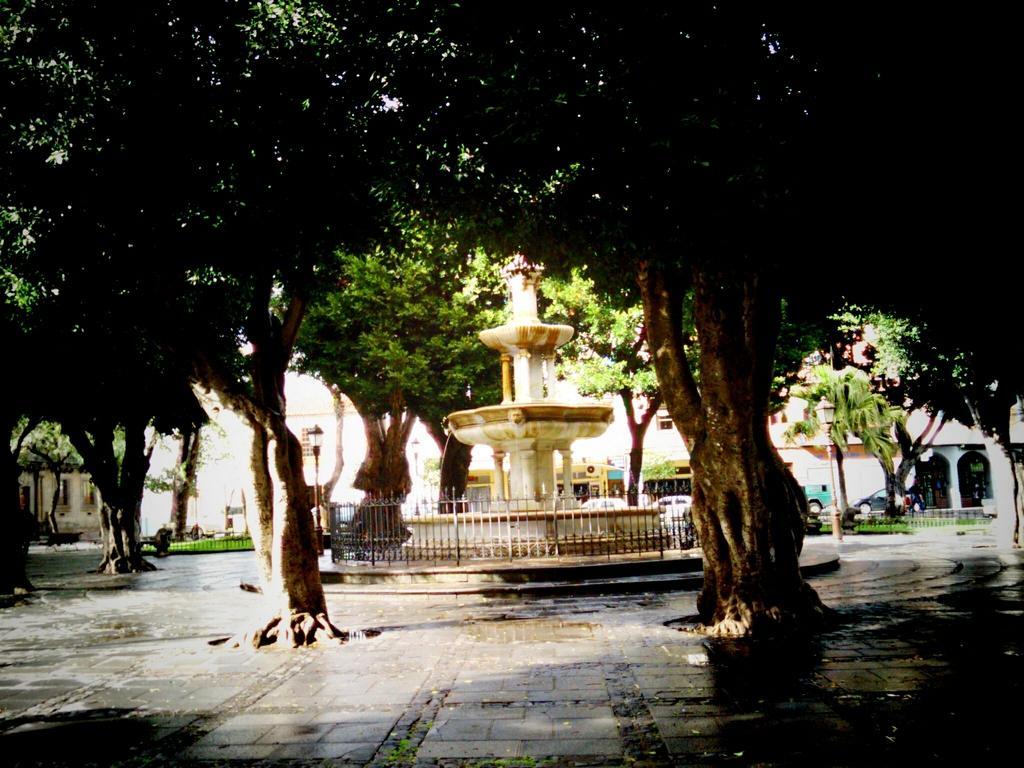What is the main feature in the center of the image? There is a fountain in the middle of the image. What surrounds the fountain? There are many trees around the fountain. What can be seen in the distance behind the fountain? There is a building in the background of the image. What else is visible in the background? There are vehicles visible in the background of the image. What type of coat is draped over the fountain in the image? There is no coat present in the image; it features a fountain surrounded by trees and a building in the background. 